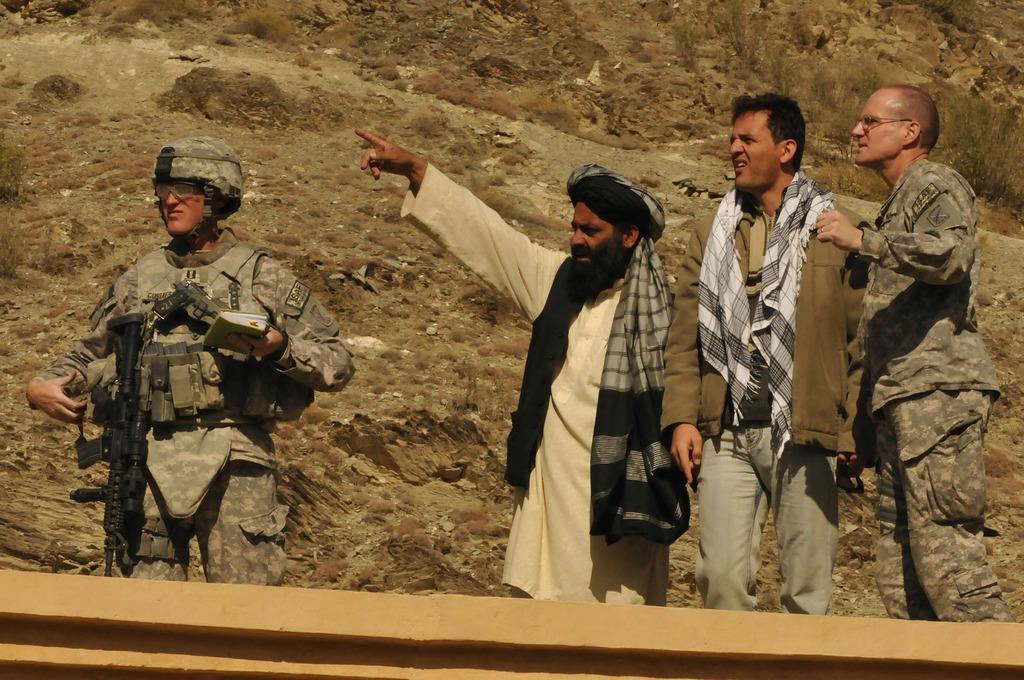In one or two sentences, can you explain what this image depicts? In the image I can see people are standing among them some are wearing uniforms, some are wearing other type of clothes. The person on the left side is carrying guns and wearing a helmet and holding some object in hands. In the background I can see the grass and some other objects. 